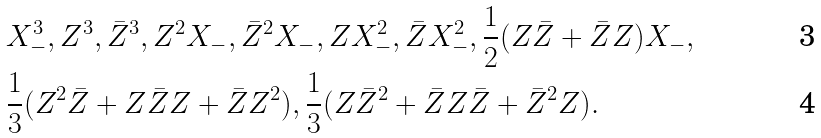Convert formula to latex. <formula><loc_0><loc_0><loc_500><loc_500>& X _ { - } ^ { 3 } , Z ^ { 3 } , \bar { Z } ^ { 3 } , Z ^ { 2 } X _ { - } , \bar { Z } ^ { 2 } X _ { - } , Z X _ { - } ^ { 2 } , \bar { Z } X _ { - } ^ { 2 } , \frac { 1 } { 2 } ( Z \bar { Z } + \bar { Z } Z ) X _ { - } , \\ & \frac { 1 } { 3 } ( Z ^ { 2 } \bar { Z } + Z \bar { Z } Z + \bar { Z } Z ^ { 2 } ) , \frac { 1 } { 3 } ( Z \bar { Z } ^ { 2 } + \bar { Z } Z \bar { Z } + \bar { Z } ^ { 2 } Z ) .</formula> 